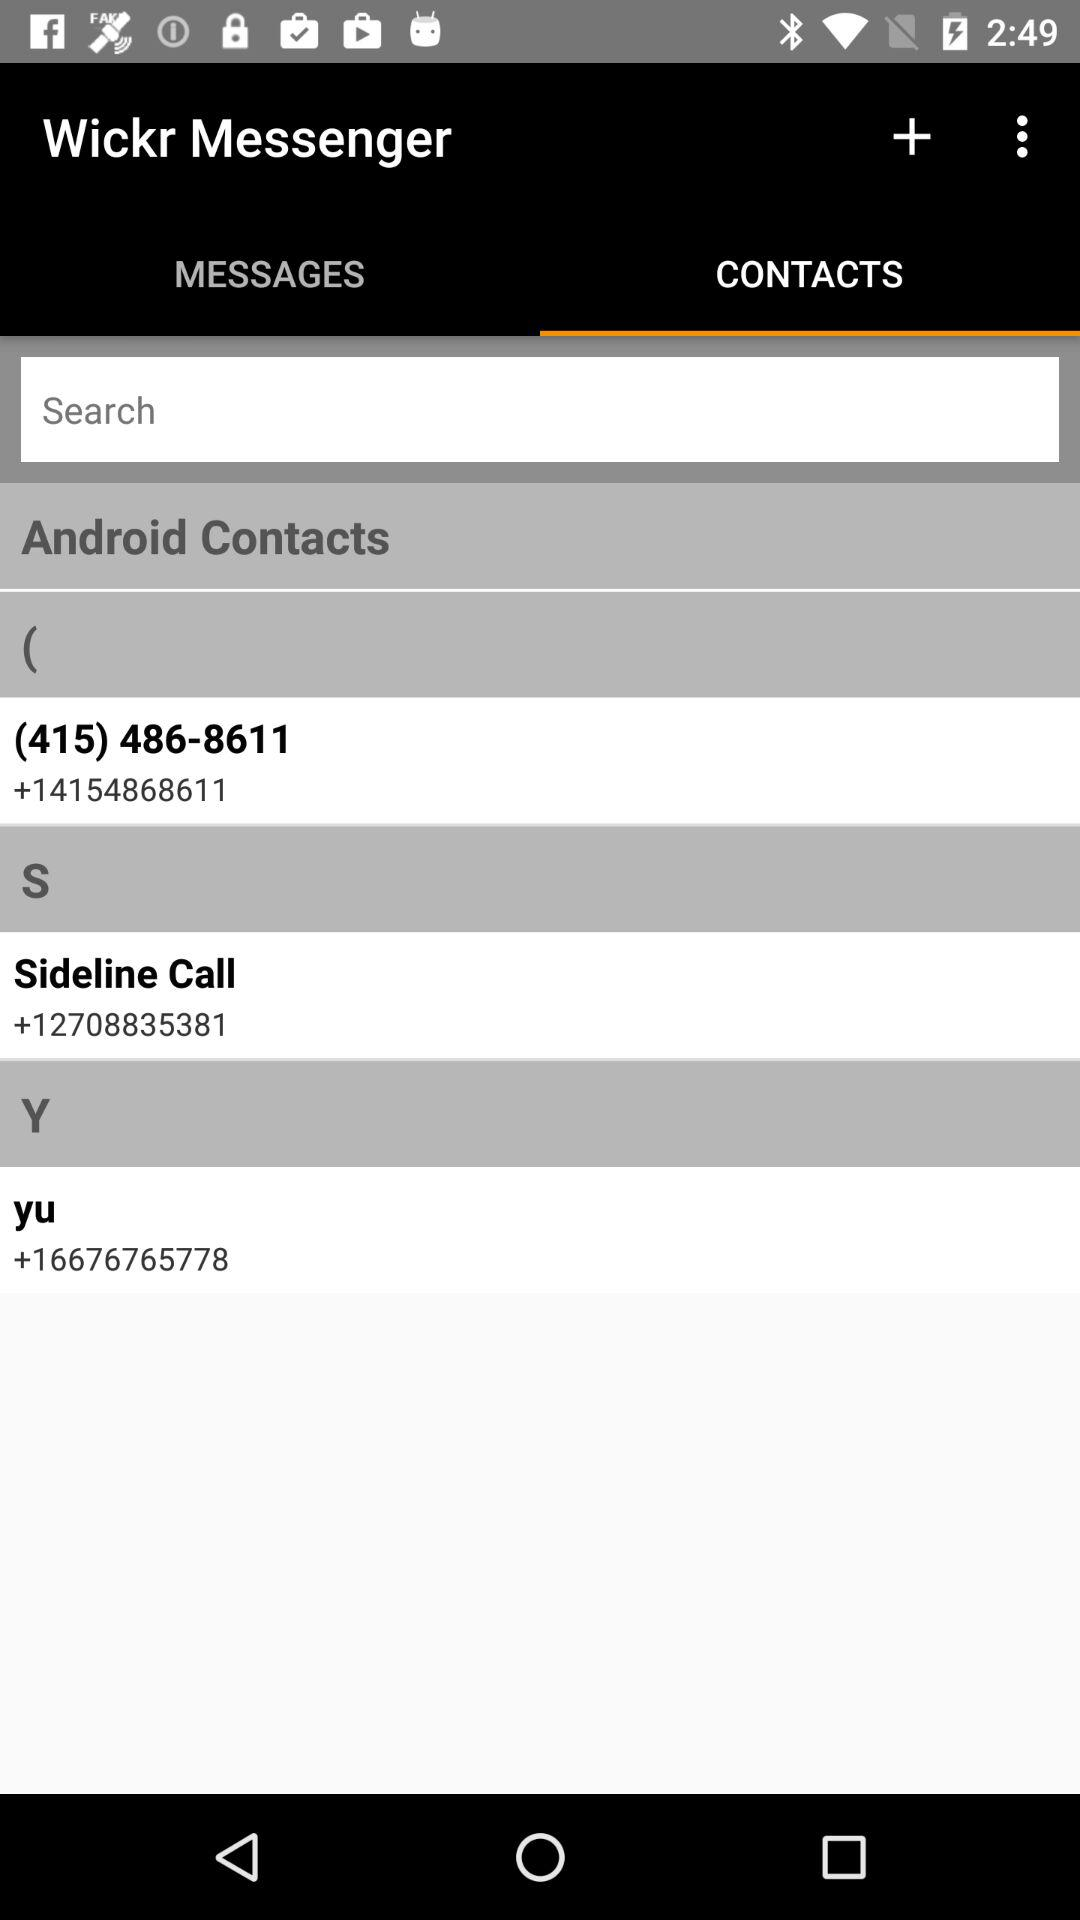What is the contact number of "Sideline Call"? The contact number of "Sideline Call" is +12708835381. 